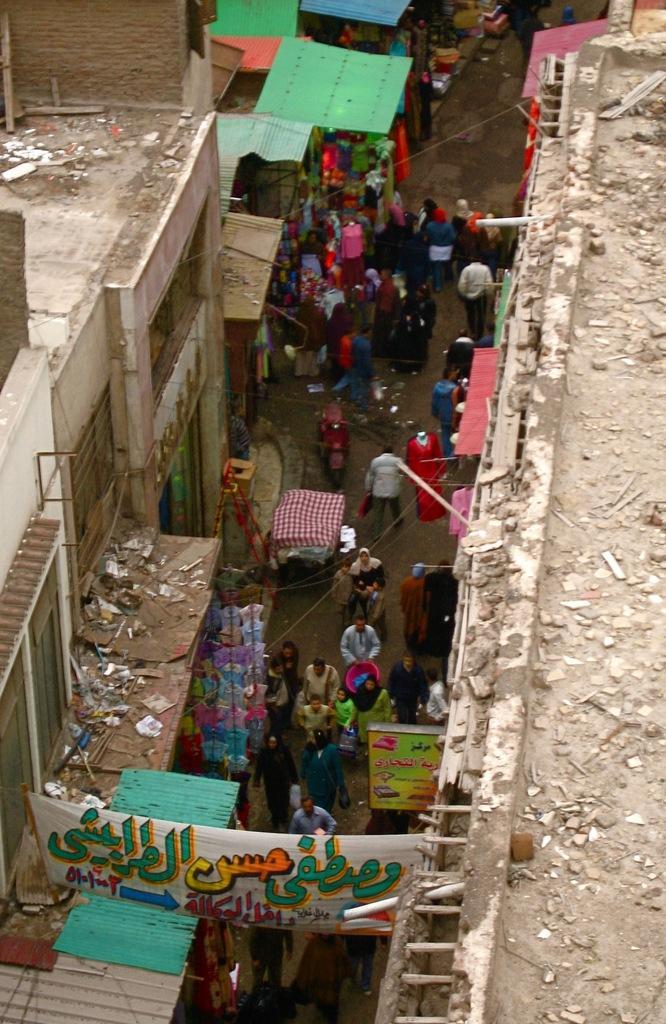How would you summarize this image in a sentence or two? In this image I can see the roofs of buildings, the street, few banners and few persons walking on the street. 